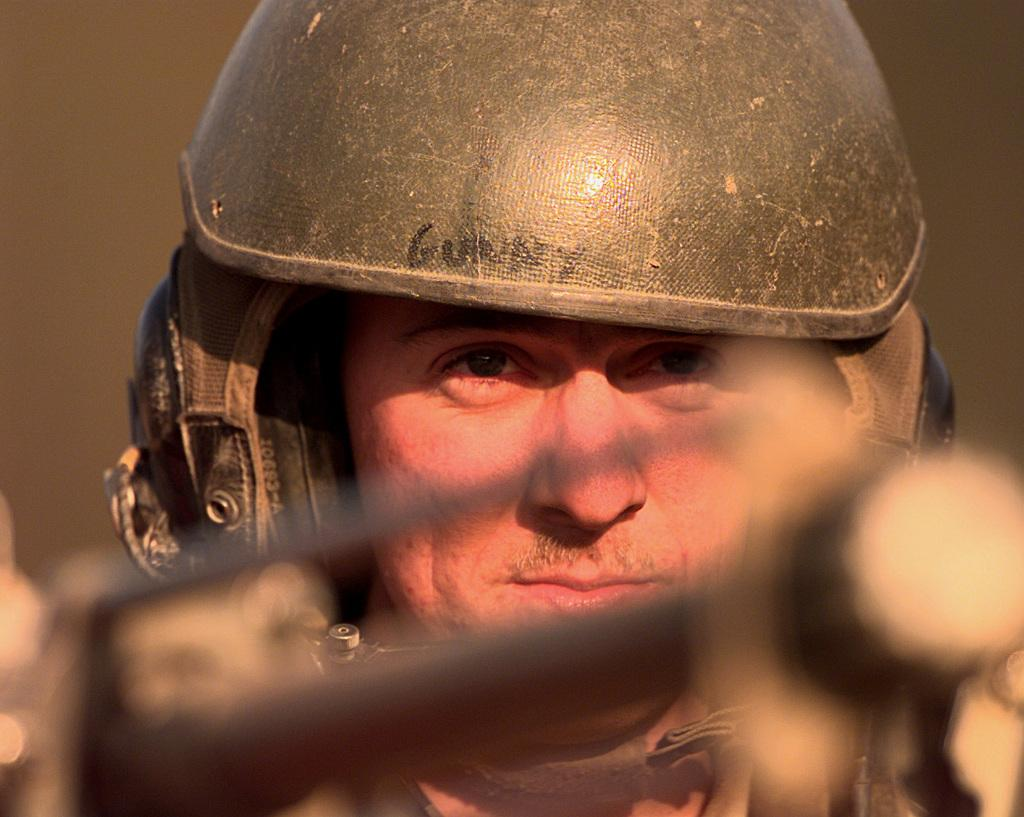What can be seen in the image? There is a person in the image. What is the person wearing? The person is wearing a helmet. What else is visible in the image? There is a weapon visible at the bottom of the image. What time of day is it in the image? The time of day cannot be determined from the image, as there are no clues to suggest whether it is morning, afternoon, or evening. 